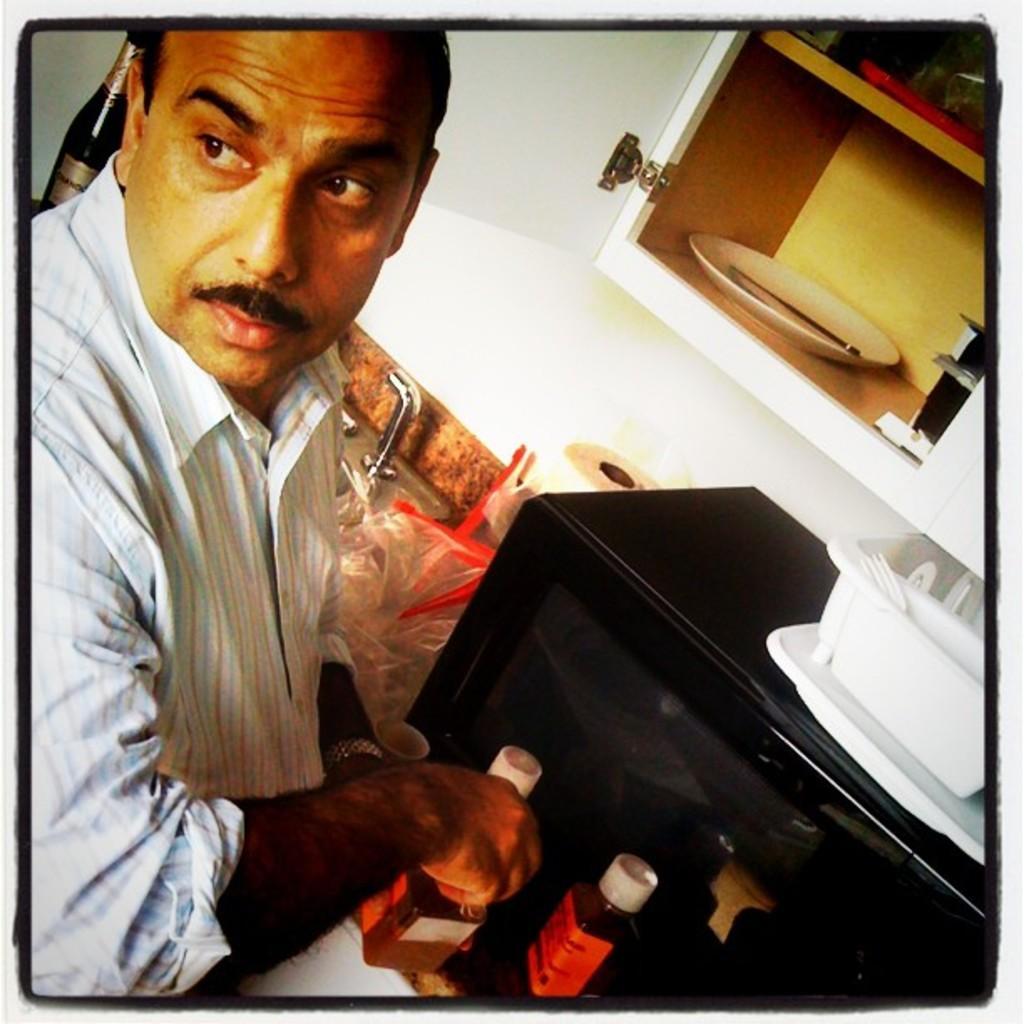Please provide a concise description of this image. In this image there is a person. There is an oven. There is a plate. There is a container. At the top there is a cupboard. 